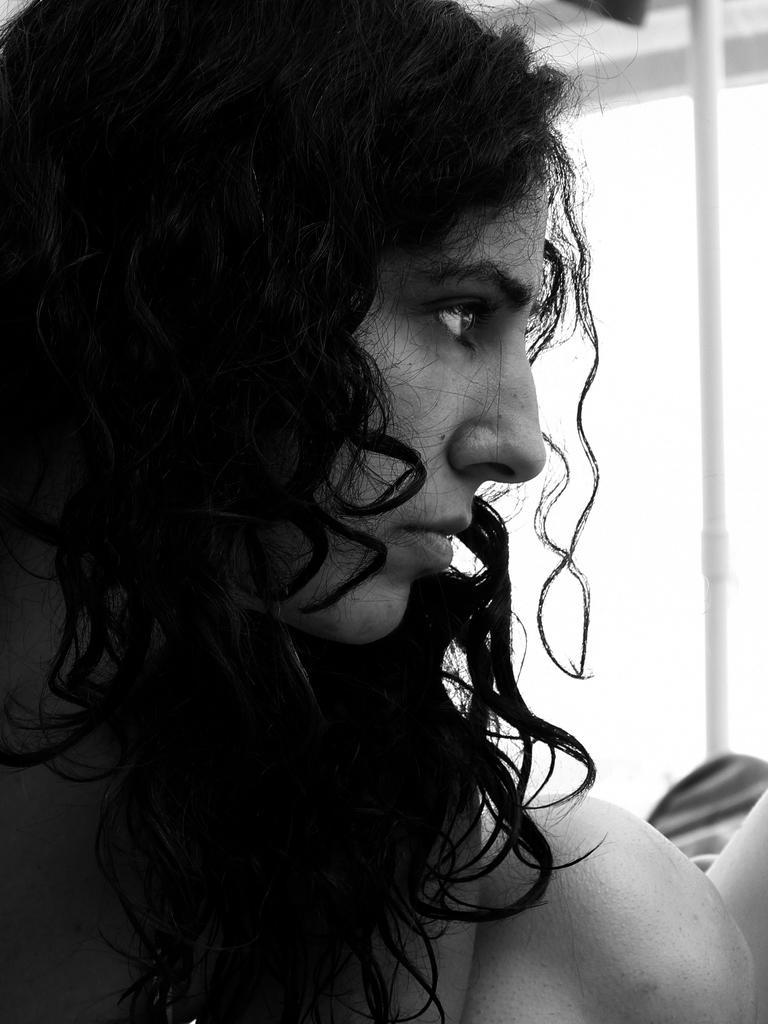Describe this image in one or two sentences. In this image I can see a woman is looking on the right side, this image is in black and white color. 